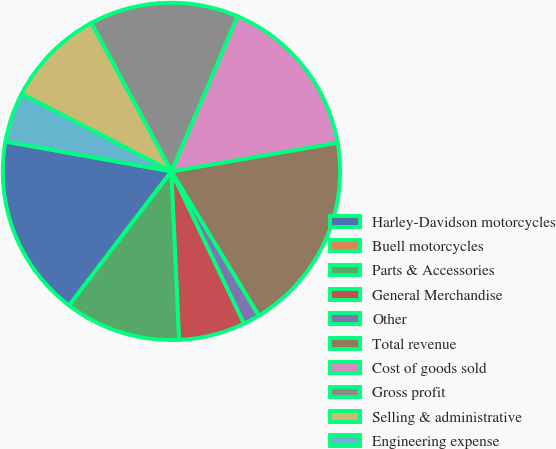Convert chart. <chart><loc_0><loc_0><loc_500><loc_500><pie_chart><fcel>Harley-Davidson motorcycles<fcel>Buell motorcycles<fcel>Parts & Accessories<fcel>General Merchandise<fcel>Other<fcel>Total revenue<fcel>Cost of goods sold<fcel>Gross profit<fcel>Selling & administrative<fcel>Engineering expense<nl><fcel>17.46%<fcel>0.0%<fcel>11.11%<fcel>6.35%<fcel>1.59%<fcel>19.04%<fcel>15.87%<fcel>14.28%<fcel>9.52%<fcel>4.76%<nl></chart> 